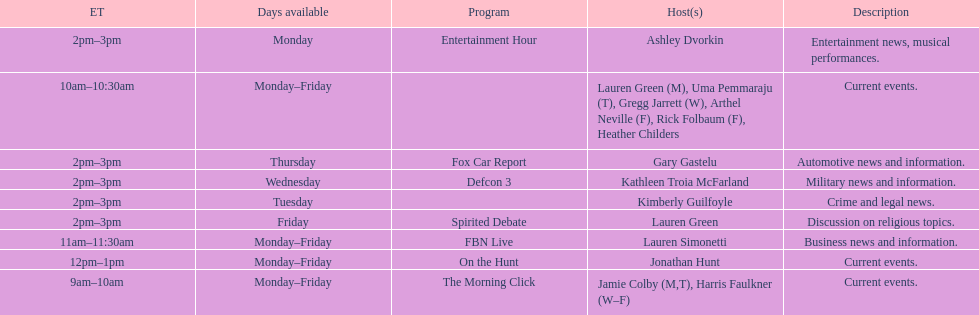How many days is fbn live available each week? 5. 